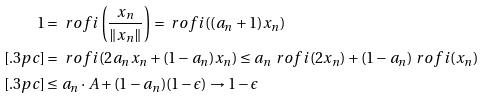<formula> <loc_0><loc_0><loc_500><loc_500>1 & = \ r o f i \left ( \frac { x _ { n } } { \| x _ { n } \| } \right ) = \ r o f i ( ( a _ { n } + 1 ) x _ { n } ) \\ [ . 3 p c ] & = \ r o f i ( 2 a _ { n } x _ { n } + ( 1 - a _ { n } ) x _ { n } ) \leq a _ { n } \ r o f i ( 2 x _ { n } ) + ( 1 - a _ { n } ) \ r o f i ( x _ { n } ) \\ [ . 3 p c ] & \leq a _ { n } \cdot A + ( 1 - a _ { n } ) ( 1 - \epsilon ) \rightarrow 1 - \epsilon</formula> 